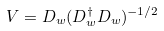<formula> <loc_0><loc_0><loc_500><loc_500>V = D _ { w } ( D _ { w } ^ { \dagger } D _ { w } ) ^ { - 1 / 2 }</formula> 